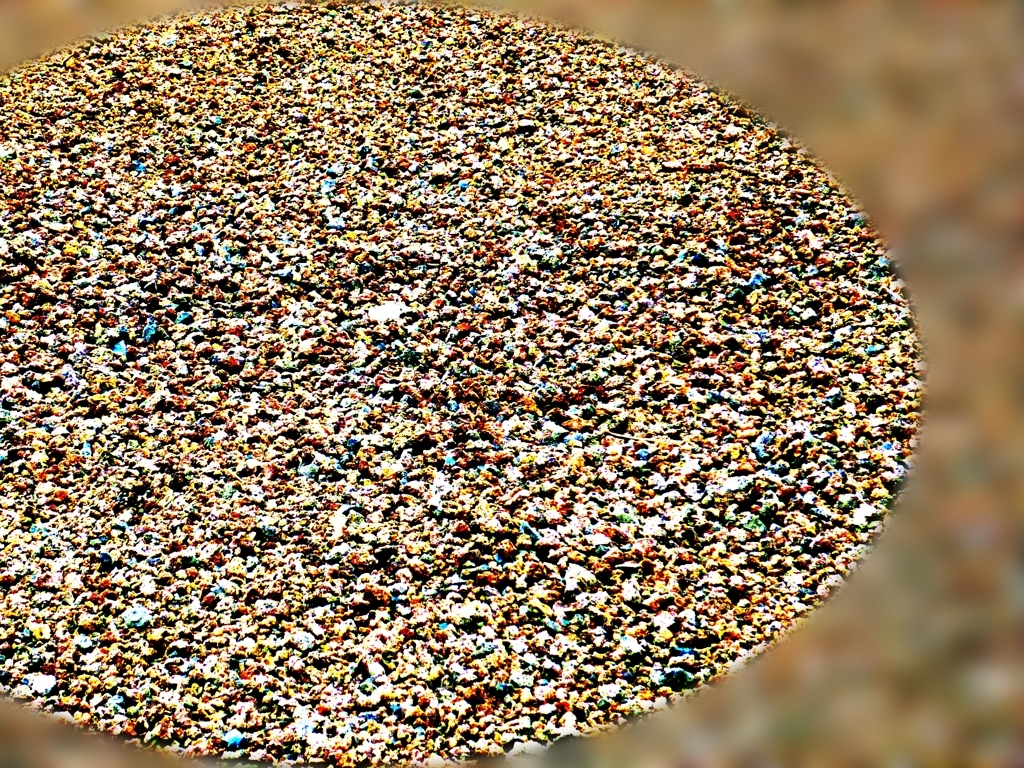What are the different colors you can identify in this image? The image features a vibrant tapestry of colors, including shades of blue, green, yellow, red, and hints of white. This colorful mosaic may represent various individual elements, each contributing to the overall dazzling effect. Does the image seem to have any pattern or organization? At first glance, the image lacks a clear pattern or organization, presenting a more spontaneous or random array of colors and shapes. However, upon closer inspection, you might identify areas where certain colors cluster, suggesting some form of underlying structure or grouping. 